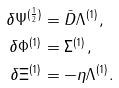<formula> <loc_0><loc_0><loc_500><loc_500>\delta \Psi ^ { ( \frac { 1 } { 2 } ) } & = \bar { D } \Lambda ^ { ( 1 ) } , \\ \delta \Phi ^ { ( 1 ) } & = \Sigma ^ { ( 1 ) } , \\ \delta \Xi ^ { ( 1 ) } & = - \eta \Lambda ^ { ( 1 ) } .</formula> 